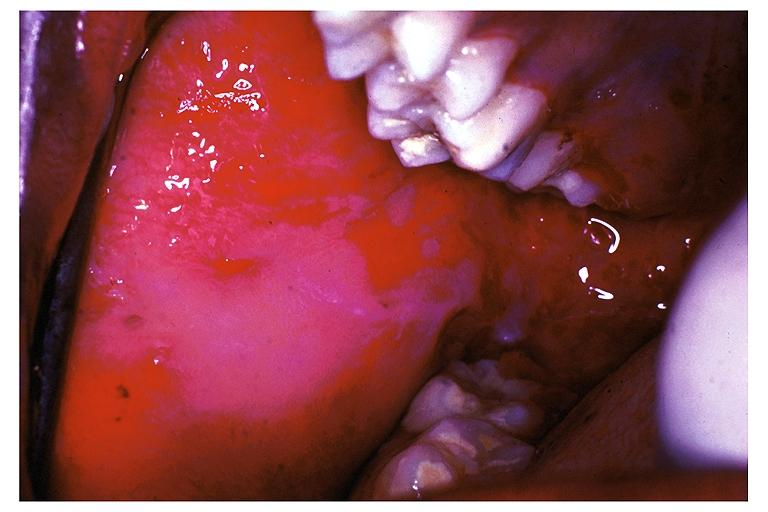s hypertrophic gastritis present?
Answer the question using a single word or phrase. No 